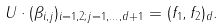<formula> <loc_0><loc_0><loc_500><loc_500>U \cdot ( \beta _ { i , j } ) _ { i = 1 , 2 ; j = 1 , \dots , d + 1 } = ( f _ { 1 } , f _ { 2 } ) _ { d } .</formula> 